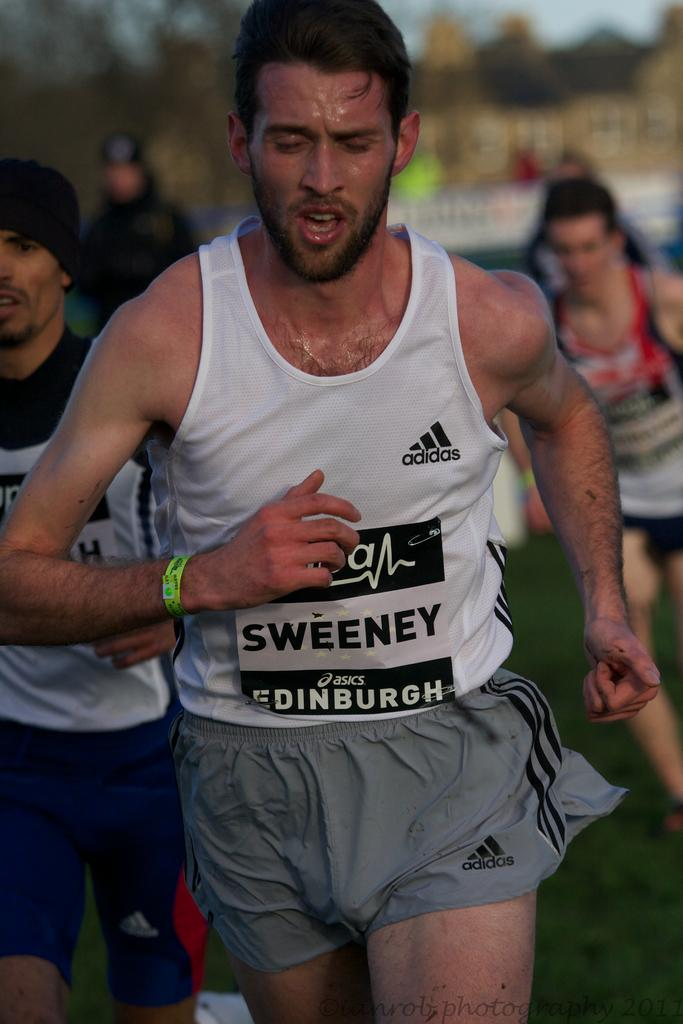<image>
Share a concise interpretation of the image provided. A runner in the race is named Sweeney and he's running for Edinburgh. 